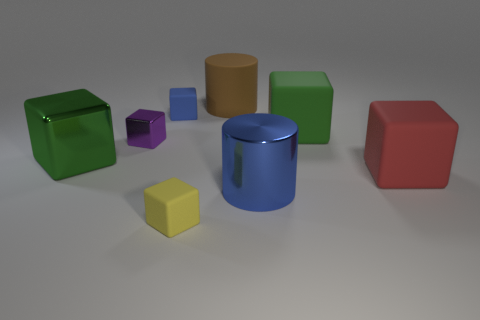The large cube that is both to the right of the blue cube and to the left of the red cube is what color? green 